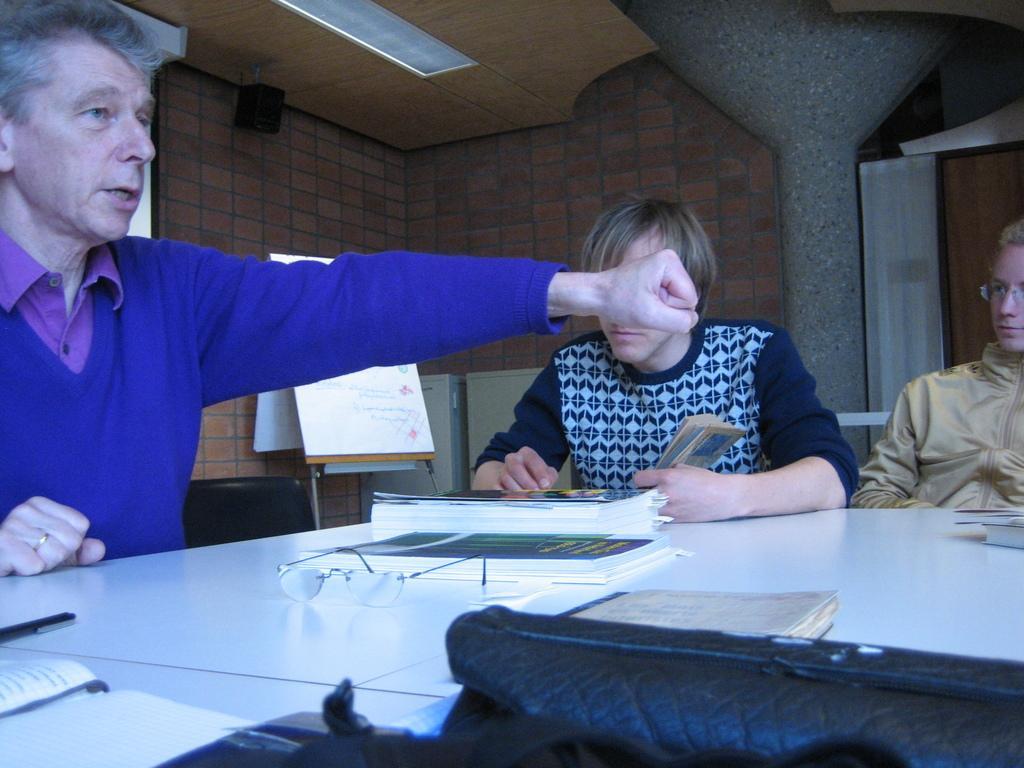Could you give a brief overview of what you see in this image? Here we can see a group of people sitting in chairs, table in front of them and here we can see spectacles and books present on the table and behind then we can see a board and a speaker present 